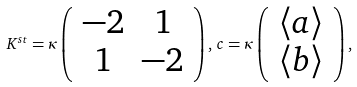Convert formula to latex. <formula><loc_0><loc_0><loc_500><loc_500>K ^ { s t } = \kappa \left ( \begin{array} { c c } - 2 & 1 \\ 1 & - 2 \end{array} \right ) , \, c = \kappa \left ( \begin{array} { c } \langle a \rangle \\ \langle b \rangle \end{array} \right ) ,</formula> 